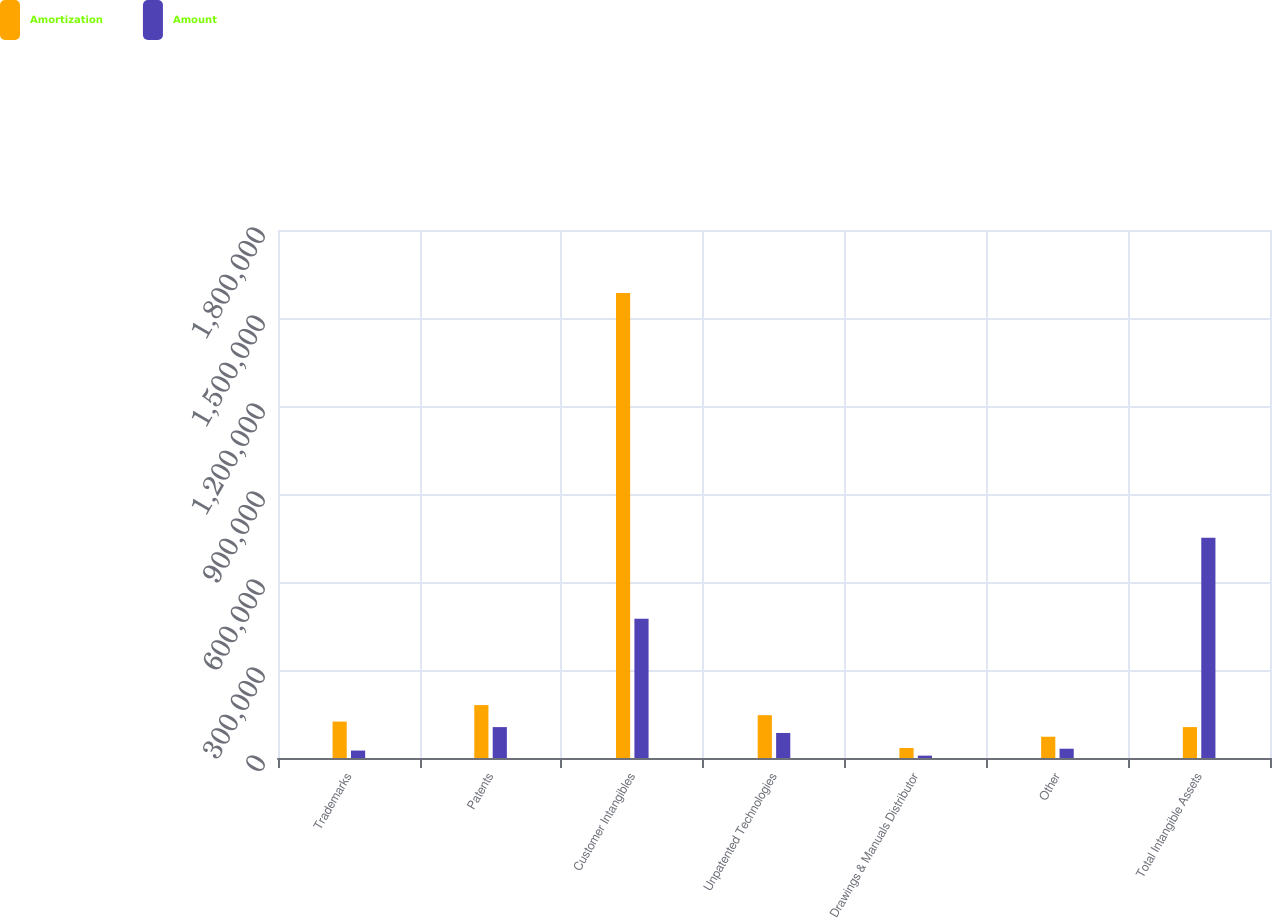<chart> <loc_0><loc_0><loc_500><loc_500><stacked_bar_chart><ecel><fcel>Trademarks<fcel>Patents<fcel>Customer Intangibles<fcel>Unpatented Technologies<fcel>Drawings & Manuals Distributor<fcel>Other<fcel>Total Intangible Assets<nl><fcel>Amortization<fcel>124129<fcel>180427<fcel>1.58504e+06<fcel>146025<fcel>34120<fcel>72514<fcel>105369<nl><fcel>Amount<fcel>25364<fcel>105369<fcel>474309<fcel>85373<fcel>8035<fcel>31650<fcel>750915<nl></chart> 